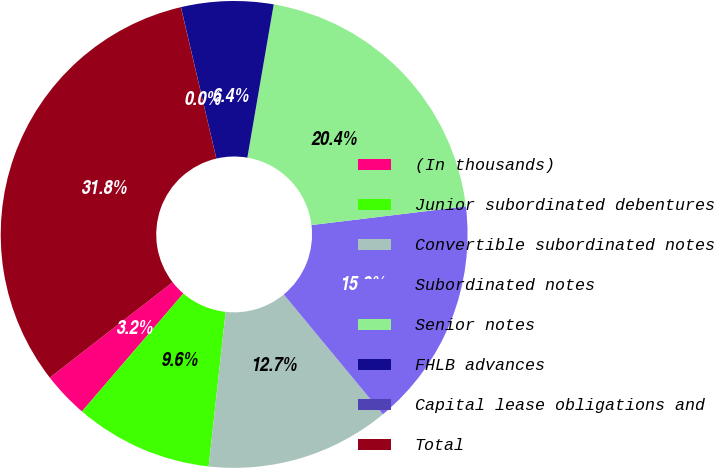Convert chart to OTSL. <chart><loc_0><loc_0><loc_500><loc_500><pie_chart><fcel>(In thousands)<fcel>Junior subordinated debentures<fcel>Convertible subordinated notes<fcel>Subordinated notes<fcel>Senior notes<fcel>FHLB advances<fcel>Capital lease obligations and<fcel>Total<nl><fcel>3.19%<fcel>9.56%<fcel>12.74%<fcel>15.92%<fcel>20.37%<fcel>6.37%<fcel>0.01%<fcel>31.84%<nl></chart> 